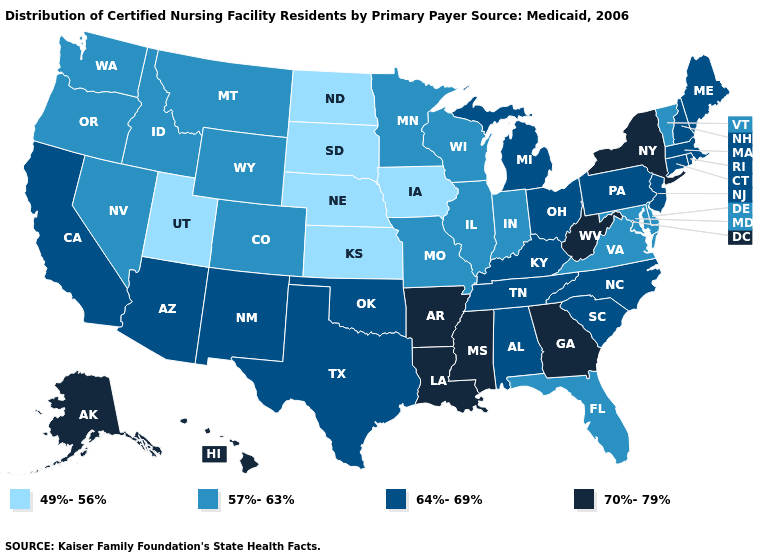Does Hawaii have the lowest value in the West?
Concise answer only. No. Name the states that have a value in the range 49%-56%?
Be succinct. Iowa, Kansas, Nebraska, North Dakota, South Dakota, Utah. Among the states that border Wyoming , which have the highest value?
Short answer required. Colorado, Idaho, Montana. What is the lowest value in states that border Montana?
Short answer required. 49%-56%. Does Illinois have the same value as Washington?
Concise answer only. Yes. What is the highest value in states that border Missouri?
Keep it brief. 70%-79%. Among the states that border South Carolina , which have the highest value?
Keep it brief. Georgia. Name the states that have a value in the range 64%-69%?
Quick response, please. Alabama, Arizona, California, Connecticut, Kentucky, Maine, Massachusetts, Michigan, New Hampshire, New Jersey, New Mexico, North Carolina, Ohio, Oklahoma, Pennsylvania, Rhode Island, South Carolina, Tennessee, Texas. Which states have the highest value in the USA?
Be succinct. Alaska, Arkansas, Georgia, Hawaii, Louisiana, Mississippi, New York, West Virginia. Does Virginia have a higher value than New Jersey?
Short answer required. No. What is the value of Indiana?
Be succinct. 57%-63%. Name the states that have a value in the range 70%-79%?
Write a very short answer. Alaska, Arkansas, Georgia, Hawaii, Louisiana, Mississippi, New York, West Virginia. What is the value of South Dakota?
Write a very short answer. 49%-56%. Name the states that have a value in the range 57%-63%?
Quick response, please. Colorado, Delaware, Florida, Idaho, Illinois, Indiana, Maryland, Minnesota, Missouri, Montana, Nevada, Oregon, Vermont, Virginia, Washington, Wisconsin, Wyoming. What is the value of Nevada?
Short answer required. 57%-63%. 